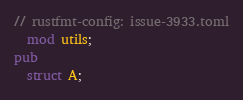Convert code to text. <code><loc_0><loc_0><loc_500><loc_500><_Rust_>// rustfmt-config: issue-3933.toml
  mod utils;
pub 
  struct A;</code> 